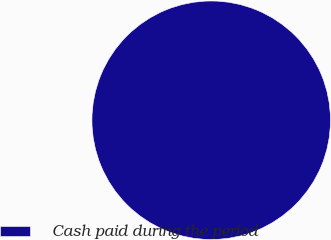Convert chart. <chart><loc_0><loc_0><loc_500><loc_500><pie_chart><fcel>Cash paid during the period<nl><fcel>100.0%<nl></chart> 